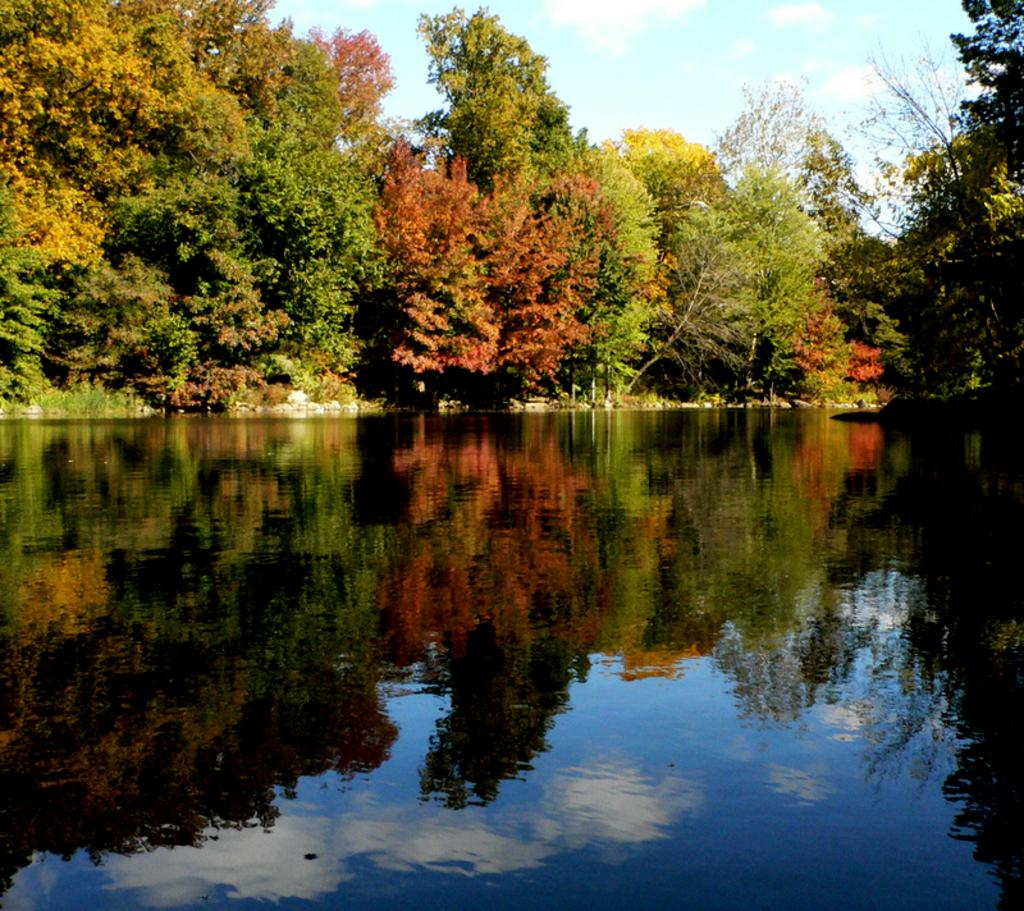What type of vegetation can be seen in the image? There are trees in the image. How would you describe the sky in the image? The sky is blue and cloudy in the image. What natural element is visible in the image besides the trees? There is water visible in the image. Can you tell me how many haircuts are being given in the image? There is no reference to haircuts or any people in the image, so it's not possible to determine how many haircuts might be happening. 